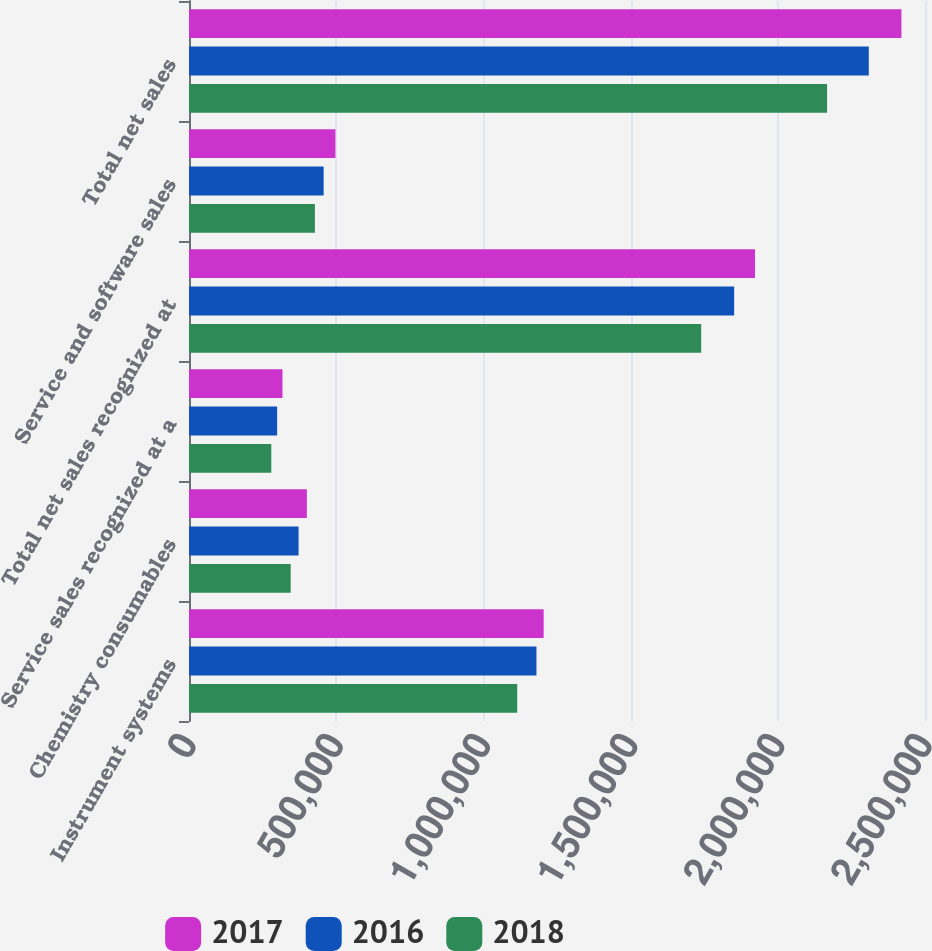<chart> <loc_0><loc_0><loc_500><loc_500><stacked_bar_chart><ecel><fcel>Instrument systems<fcel>Chemistry consumables<fcel>Service sales recognized at a<fcel>Total net sales recognized at<fcel>Service and software sales<fcel>Total net sales<nl><fcel>2017<fcel>1.20471e+06<fcel>400287<fcel>317549<fcel>1.92254e+06<fcel>497387<fcel>2.41993e+06<nl><fcel>2016<fcel>1.18019e+06<fcel>372157<fcel>299385<fcel>1.85173e+06<fcel>457344<fcel>2.30908e+06<nl><fcel>2018<fcel>1.11488e+06<fcel>345413<fcel>279482<fcel>1.73978e+06<fcel>427645<fcel>2.16742e+06<nl></chart> 